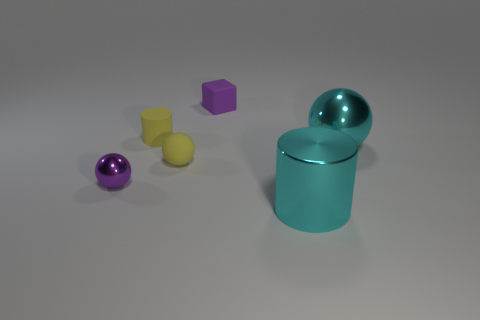Add 3 small yellow rubber cylinders. How many objects exist? 9 Subtract all blocks. How many objects are left? 5 Add 1 large things. How many large things exist? 3 Subtract 0 red balls. How many objects are left? 6 Subtract all small yellow rubber cylinders. Subtract all blocks. How many objects are left? 4 Add 4 small yellow rubber cylinders. How many small yellow rubber cylinders are left? 5 